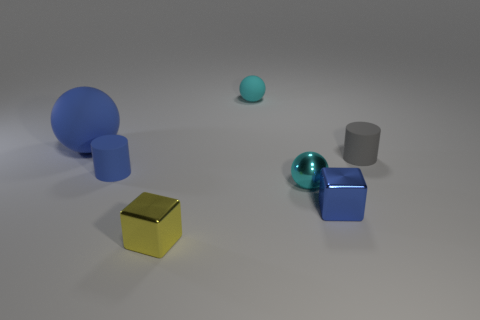What number of other things are the same color as the large object?
Make the answer very short. 2. What color is the big object?
Provide a succinct answer. Blue. There is a rubber object that is right of the small yellow object and in front of the blue ball; what size is it?
Provide a short and direct response. Small. What number of objects are either tiny objects in front of the big ball or tiny cyan balls?
Provide a succinct answer. 6. The small cyan thing that is made of the same material as the big blue sphere is what shape?
Your response must be concise. Sphere. What shape is the large blue object?
Ensure brevity in your answer.  Sphere. There is a tiny thing that is both behind the tiny blue rubber thing and to the left of the shiny sphere; what is its color?
Make the answer very short. Cyan. What shape is the gray rubber object that is the same size as the shiny ball?
Keep it short and to the point. Cylinder. Is there a small yellow metal thing that has the same shape as the large blue object?
Your answer should be very brief. No. Do the big blue ball and the small cylinder that is on the left side of the small blue shiny block have the same material?
Give a very brief answer. Yes. 